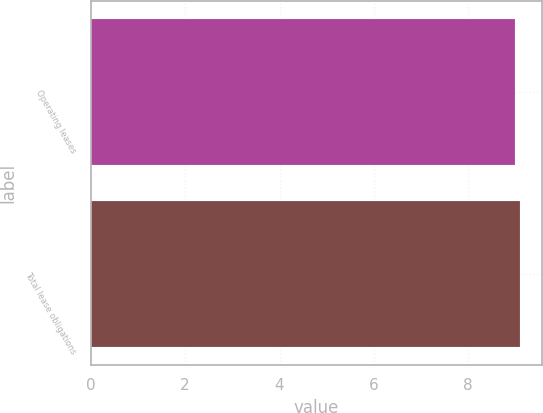Convert chart. <chart><loc_0><loc_0><loc_500><loc_500><bar_chart><fcel>Operating leases<fcel>Total lease obligations<nl><fcel>9<fcel>9.1<nl></chart> 